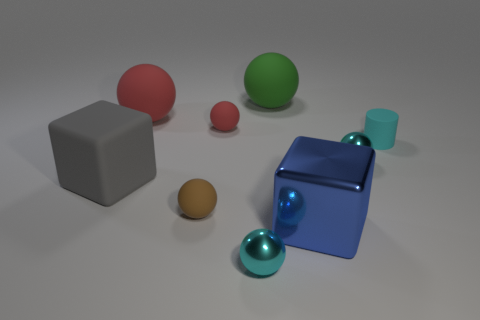Subtract all yellow cylinders. How many cyan spheres are left? 2 Subtract all shiny spheres. How many spheres are left? 4 Subtract 4 spheres. How many spheres are left? 2 Subtract all green spheres. How many spheres are left? 5 Subtract all balls. How many objects are left? 3 Subtract 1 cyan cylinders. How many objects are left? 8 Subtract all cyan balls. Subtract all yellow cylinders. How many balls are left? 4 Subtract all brown rubber things. Subtract all rubber things. How many objects are left? 2 Add 5 tiny rubber objects. How many tiny rubber objects are left? 8 Add 1 tiny matte cylinders. How many tiny matte cylinders exist? 2 